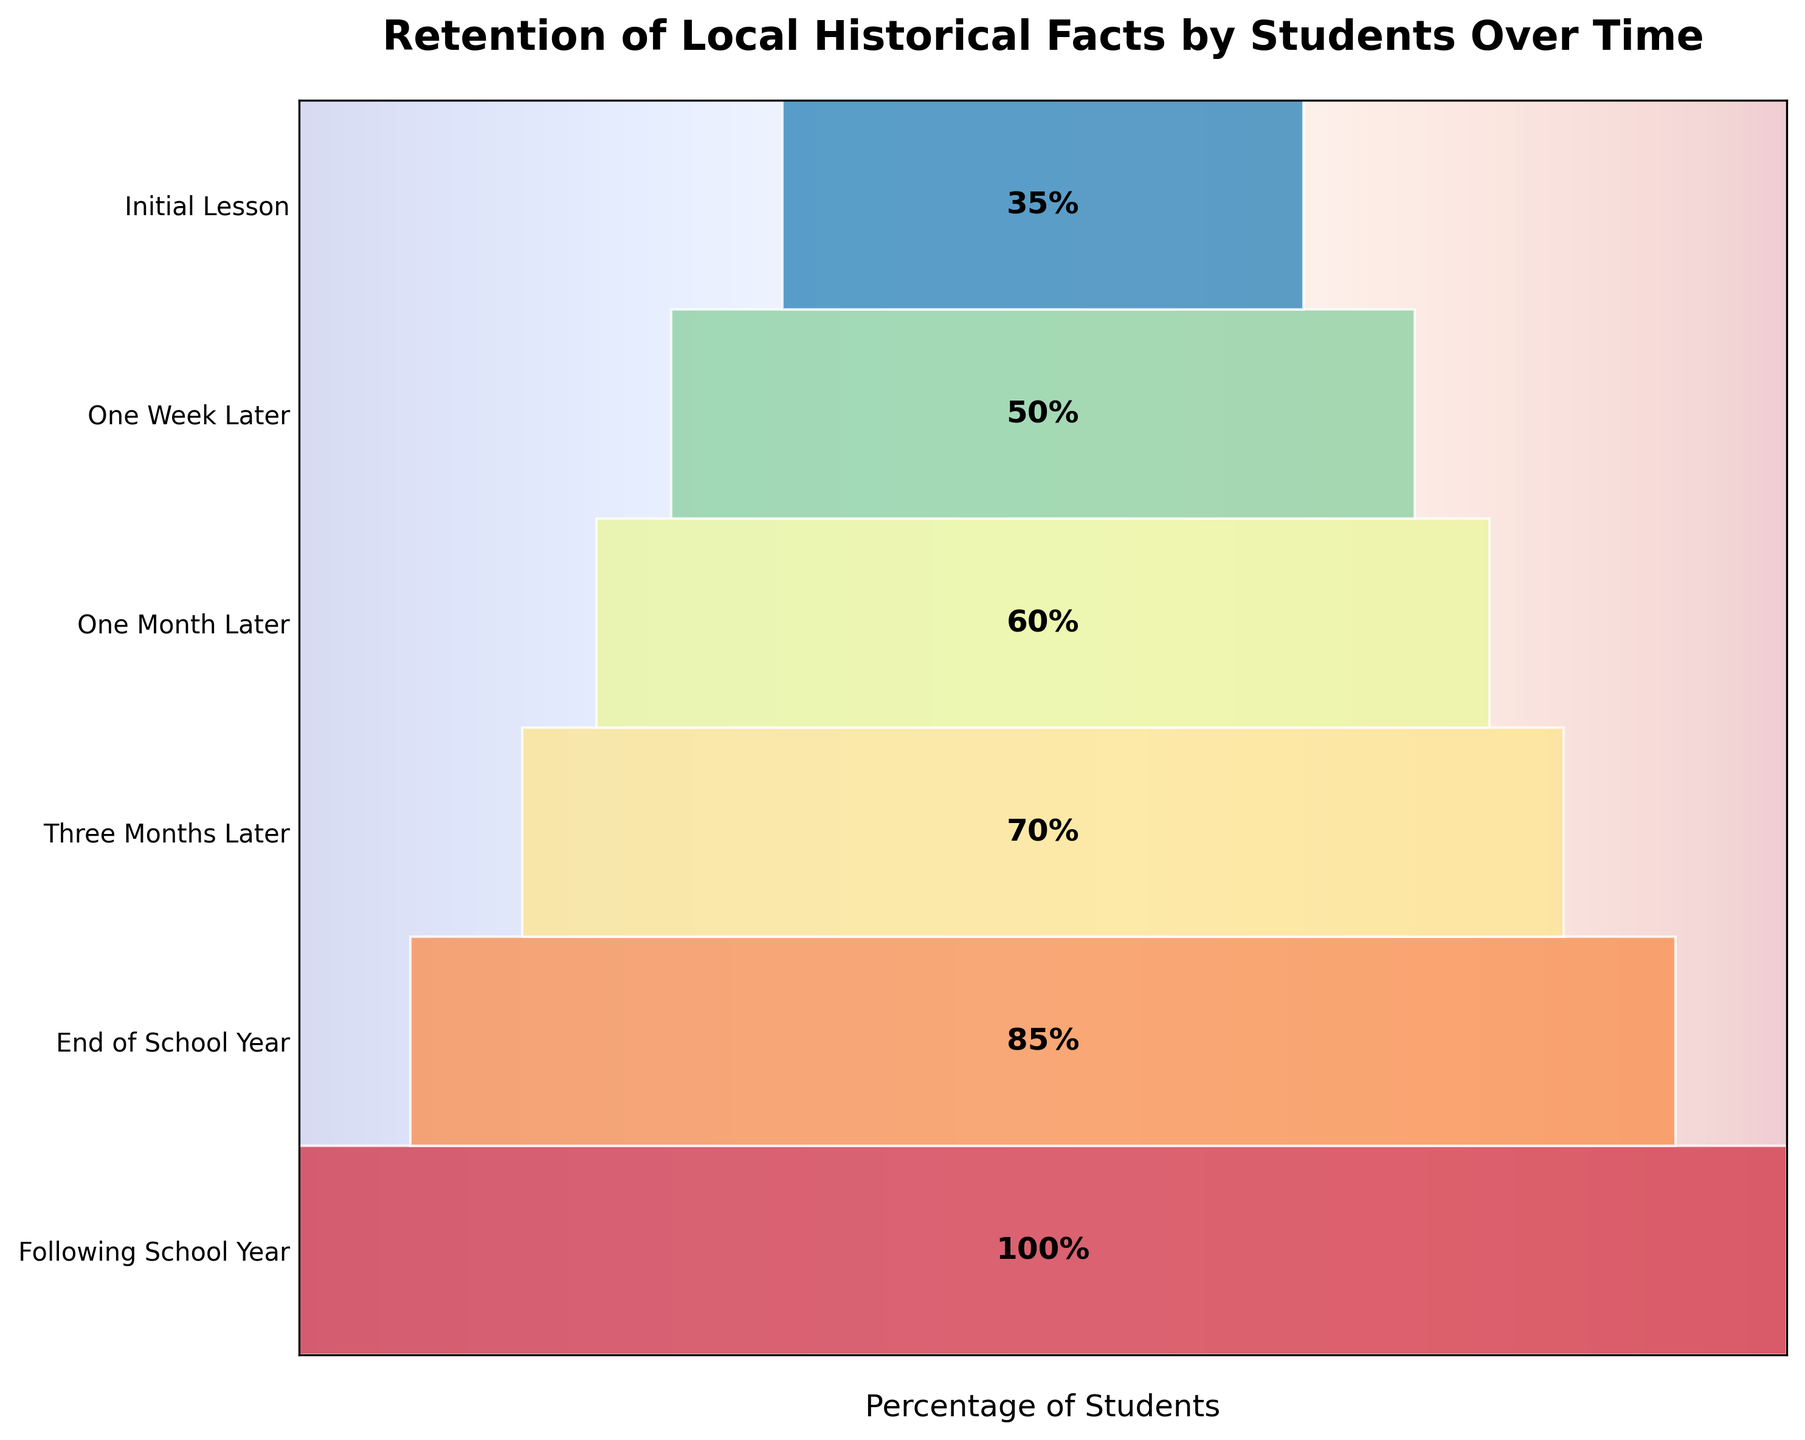What is the title of the funnel chart? The title is usually located at the top of the figure. Here, the visible title reads as 'Retention of Local Historical Facts by Students Over Time'.
Answer: Retention of Local Historical Facts by Students Over Time How many stages are represented in the funnel chart? By counting the number of distinct stages listed in the vertical direction of the funnel chart, you can determine the total number of stages.
Answer: 6 What percentage of students retained historical facts one week after the initial lesson? Locate the segment labeled "One Week Later" on the funnel chart and read the percentage within this segment.
Answer: 85% What is the difference in retention percentage between 'One Month Later' and 'Three Months Later'? Find the percentages for 'One Month Later' (70%) and 'Three Months Later' (60%). Subtract the latter from the former: 70% - 60% = 10%.
Answer: 10% Which stage shows the lowest percentage of student retention? Look for the segment with the smallest percentage value. 'Following School Year' is labeled with the lowest percentage, which is 35%.
Answer: Following School Year How does the retention percentage change from the 'Initial Lesson' to the 'End of School Year'? Compare the percentage at the 'Initial Lesson' (100%) with the percentage at the 'End of School Year' (50%). The percentage drops from 100% to 50%, showing a decrease of 50%.
Answer: Decreases by 50% Is the decrease in retention percentage larger from 'Three Months Later' to 'End of School Year' or from 'End of School Year' to 'Following School Year'? Calculate the difference for each interval: from 'Three Months Later' (60%) to 'End of School Year' (50%) is 10%, and from 'End of School Year' (50%) to 'Following School Year' (35%) is 15%. 15% > 10%, so the decrease is larger from 'End of School Year' to 'Following School Year'.
Answer: From 'End of School Year' to 'Following School Year' What is the average retention percentage across all stages? Add all retention percentages: 100% + 85% + 70% + 60% + 50% + 35% = 400%. Then divide by the number of stages (6): 400% / 6 ≈ 66.67%.
Answer: 66.67% Compare the retention percentage one week after the initial lesson to the retention percentage at the end of the school year. Which is greater and by how much? Compare the percentages at 'One Week Later' (85%) and 'End of School Year' (50%). The difference is 85% - 50% = 35%. So, the retention percentage one week after is greater by 35%.
Answer: One Week Later by 35% Is the overall trend of student retention increasing or decreasing over time? Observing the funnel chart shows a consistent decrease in the percentage of students retained at each subsequent stage.
Answer: Decreasing 